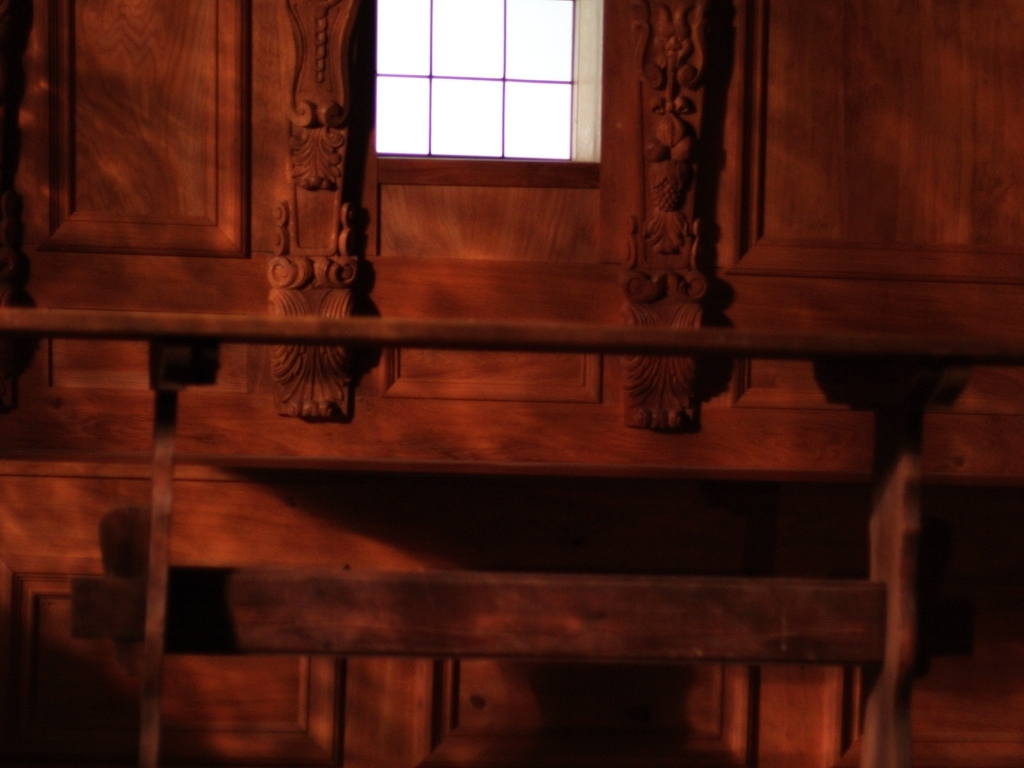What mood does the lighting in this image convey? The subdued lighting and warm tones create an intimate and somewhat mysterious atmosphere, which could be indicative of a peaceful, contemplative moment, or possibly a prelude to something more dramatic. 